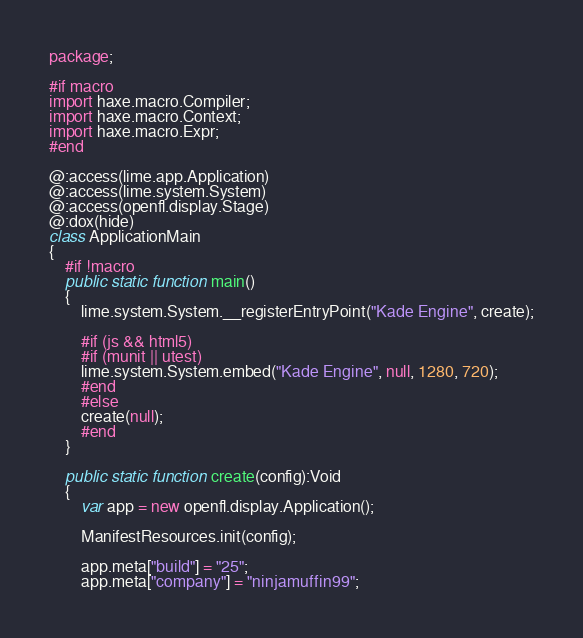<code> <loc_0><loc_0><loc_500><loc_500><_Haxe_>package;

#if macro
import haxe.macro.Compiler;
import haxe.macro.Context;
import haxe.macro.Expr;
#end

@:access(lime.app.Application)
@:access(lime.system.System)
@:access(openfl.display.Stage)
@:dox(hide)
class ApplicationMain
{
	#if !macro
	public static function main()
	{
		lime.system.System.__registerEntryPoint("Kade Engine", create);

		#if (js && html5)
		#if (munit || utest)
		lime.system.System.embed("Kade Engine", null, 1280, 720);
		#end
		#else
		create(null);
		#end
	}

	public static function create(config):Void
	{
		var app = new openfl.display.Application();

		ManifestResources.init(config);

		app.meta["build"] = "25";
		app.meta["company"] = "ninjamuffin99";</code> 